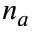<formula> <loc_0><loc_0><loc_500><loc_500>n _ { a }</formula> 